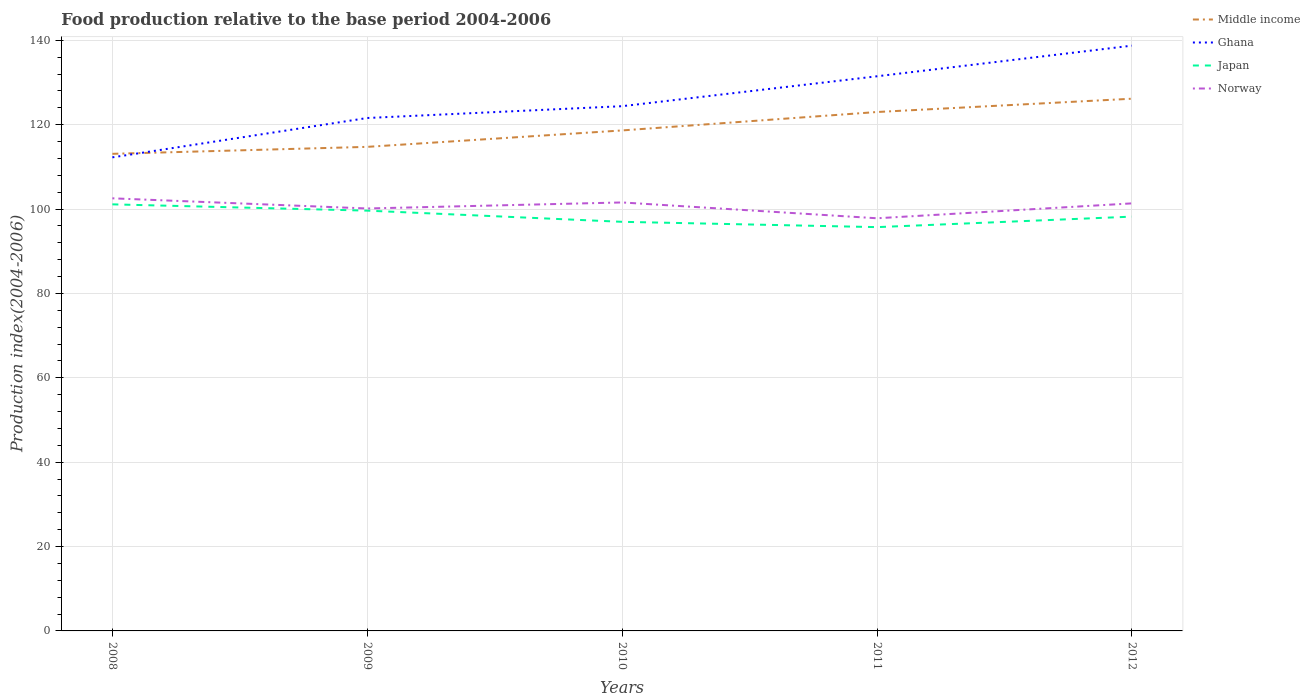How many different coloured lines are there?
Provide a short and direct response. 4. Is the number of lines equal to the number of legend labels?
Make the answer very short. Yes. Across all years, what is the maximum food production index in Japan?
Offer a terse response. 95.72. In which year was the food production index in Middle income maximum?
Ensure brevity in your answer.  2008. What is the total food production index in Middle income in the graph?
Offer a terse response. -3.9. What is the difference between the highest and the second highest food production index in Norway?
Ensure brevity in your answer.  4.73. What is the difference between the highest and the lowest food production index in Japan?
Give a very brief answer. 2. Is the food production index in Norway strictly greater than the food production index in Ghana over the years?
Ensure brevity in your answer.  Yes. How many lines are there?
Ensure brevity in your answer.  4. How many years are there in the graph?
Your response must be concise. 5. Are the values on the major ticks of Y-axis written in scientific E-notation?
Give a very brief answer. No. Does the graph contain any zero values?
Your answer should be compact. No. Does the graph contain grids?
Ensure brevity in your answer.  Yes. How are the legend labels stacked?
Offer a very short reply. Vertical. What is the title of the graph?
Ensure brevity in your answer.  Food production relative to the base period 2004-2006. Does "Kuwait" appear as one of the legend labels in the graph?
Your response must be concise. No. What is the label or title of the X-axis?
Offer a terse response. Years. What is the label or title of the Y-axis?
Make the answer very short. Production index(2004-2006). What is the Production index(2004-2006) of Middle income in 2008?
Your response must be concise. 113.1. What is the Production index(2004-2006) of Ghana in 2008?
Ensure brevity in your answer.  112.26. What is the Production index(2004-2006) of Japan in 2008?
Ensure brevity in your answer.  101.12. What is the Production index(2004-2006) in Norway in 2008?
Offer a very short reply. 102.55. What is the Production index(2004-2006) in Middle income in 2009?
Offer a very short reply. 114.75. What is the Production index(2004-2006) in Ghana in 2009?
Your answer should be compact. 121.59. What is the Production index(2004-2006) of Japan in 2009?
Ensure brevity in your answer.  99.63. What is the Production index(2004-2006) of Norway in 2009?
Your answer should be compact. 100.14. What is the Production index(2004-2006) in Middle income in 2010?
Provide a short and direct response. 118.64. What is the Production index(2004-2006) in Ghana in 2010?
Your answer should be very brief. 124.39. What is the Production index(2004-2006) in Japan in 2010?
Keep it short and to the point. 96.98. What is the Production index(2004-2006) in Norway in 2010?
Provide a short and direct response. 101.57. What is the Production index(2004-2006) of Middle income in 2011?
Your answer should be compact. 123.01. What is the Production index(2004-2006) of Ghana in 2011?
Your response must be concise. 131.48. What is the Production index(2004-2006) of Japan in 2011?
Provide a short and direct response. 95.72. What is the Production index(2004-2006) in Norway in 2011?
Ensure brevity in your answer.  97.82. What is the Production index(2004-2006) of Middle income in 2012?
Give a very brief answer. 126.16. What is the Production index(2004-2006) in Ghana in 2012?
Keep it short and to the point. 138.74. What is the Production index(2004-2006) in Japan in 2012?
Your answer should be compact. 98.21. What is the Production index(2004-2006) of Norway in 2012?
Ensure brevity in your answer.  101.35. Across all years, what is the maximum Production index(2004-2006) of Middle income?
Make the answer very short. 126.16. Across all years, what is the maximum Production index(2004-2006) of Ghana?
Provide a succinct answer. 138.74. Across all years, what is the maximum Production index(2004-2006) in Japan?
Your response must be concise. 101.12. Across all years, what is the maximum Production index(2004-2006) in Norway?
Keep it short and to the point. 102.55. Across all years, what is the minimum Production index(2004-2006) of Middle income?
Ensure brevity in your answer.  113.1. Across all years, what is the minimum Production index(2004-2006) of Ghana?
Your answer should be compact. 112.26. Across all years, what is the minimum Production index(2004-2006) in Japan?
Give a very brief answer. 95.72. Across all years, what is the minimum Production index(2004-2006) of Norway?
Provide a succinct answer. 97.82. What is the total Production index(2004-2006) of Middle income in the graph?
Offer a very short reply. 595.66. What is the total Production index(2004-2006) in Ghana in the graph?
Make the answer very short. 628.46. What is the total Production index(2004-2006) of Japan in the graph?
Give a very brief answer. 491.66. What is the total Production index(2004-2006) in Norway in the graph?
Offer a very short reply. 503.43. What is the difference between the Production index(2004-2006) in Middle income in 2008 and that in 2009?
Give a very brief answer. -1.65. What is the difference between the Production index(2004-2006) in Ghana in 2008 and that in 2009?
Offer a very short reply. -9.33. What is the difference between the Production index(2004-2006) of Japan in 2008 and that in 2009?
Give a very brief answer. 1.49. What is the difference between the Production index(2004-2006) in Norway in 2008 and that in 2009?
Provide a succinct answer. 2.41. What is the difference between the Production index(2004-2006) of Middle income in 2008 and that in 2010?
Your response must be concise. -5.55. What is the difference between the Production index(2004-2006) in Ghana in 2008 and that in 2010?
Make the answer very short. -12.13. What is the difference between the Production index(2004-2006) of Japan in 2008 and that in 2010?
Provide a short and direct response. 4.14. What is the difference between the Production index(2004-2006) of Norway in 2008 and that in 2010?
Provide a succinct answer. 0.98. What is the difference between the Production index(2004-2006) in Middle income in 2008 and that in 2011?
Offer a very short reply. -9.91. What is the difference between the Production index(2004-2006) in Ghana in 2008 and that in 2011?
Your answer should be compact. -19.22. What is the difference between the Production index(2004-2006) in Japan in 2008 and that in 2011?
Keep it short and to the point. 5.4. What is the difference between the Production index(2004-2006) in Norway in 2008 and that in 2011?
Provide a succinct answer. 4.73. What is the difference between the Production index(2004-2006) of Middle income in 2008 and that in 2012?
Ensure brevity in your answer.  -13.07. What is the difference between the Production index(2004-2006) of Ghana in 2008 and that in 2012?
Keep it short and to the point. -26.48. What is the difference between the Production index(2004-2006) of Japan in 2008 and that in 2012?
Your response must be concise. 2.91. What is the difference between the Production index(2004-2006) in Norway in 2008 and that in 2012?
Keep it short and to the point. 1.2. What is the difference between the Production index(2004-2006) of Middle income in 2009 and that in 2010?
Give a very brief answer. -3.9. What is the difference between the Production index(2004-2006) in Japan in 2009 and that in 2010?
Keep it short and to the point. 2.65. What is the difference between the Production index(2004-2006) in Norway in 2009 and that in 2010?
Offer a very short reply. -1.43. What is the difference between the Production index(2004-2006) in Middle income in 2009 and that in 2011?
Make the answer very short. -8.26. What is the difference between the Production index(2004-2006) of Ghana in 2009 and that in 2011?
Your response must be concise. -9.89. What is the difference between the Production index(2004-2006) of Japan in 2009 and that in 2011?
Ensure brevity in your answer.  3.91. What is the difference between the Production index(2004-2006) of Norway in 2009 and that in 2011?
Your answer should be compact. 2.32. What is the difference between the Production index(2004-2006) in Middle income in 2009 and that in 2012?
Provide a short and direct response. -11.41. What is the difference between the Production index(2004-2006) in Ghana in 2009 and that in 2012?
Keep it short and to the point. -17.15. What is the difference between the Production index(2004-2006) in Japan in 2009 and that in 2012?
Make the answer very short. 1.42. What is the difference between the Production index(2004-2006) in Norway in 2009 and that in 2012?
Ensure brevity in your answer.  -1.21. What is the difference between the Production index(2004-2006) in Middle income in 2010 and that in 2011?
Your response must be concise. -4.37. What is the difference between the Production index(2004-2006) in Ghana in 2010 and that in 2011?
Give a very brief answer. -7.09. What is the difference between the Production index(2004-2006) in Japan in 2010 and that in 2011?
Make the answer very short. 1.26. What is the difference between the Production index(2004-2006) of Norway in 2010 and that in 2011?
Your response must be concise. 3.75. What is the difference between the Production index(2004-2006) in Middle income in 2010 and that in 2012?
Offer a terse response. -7.52. What is the difference between the Production index(2004-2006) of Ghana in 2010 and that in 2012?
Keep it short and to the point. -14.35. What is the difference between the Production index(2004-2006) of Japan in 2010 and that in 2012?
Your answer should be compact. -1.23. What is the difference between the Production index(2004-2006) of Norway in 2010 and that in 2012?
Provide a short and direct response. 0.22. What is the difference between the Production index(2004-2006) in Middle income in 2011 and that in 2012?
Your answer should be compact. -3.15. What is the difference between the Production index(2004-2006) of Ghana in 2011 and that in 2012?
Make the answer very short. -7.26. What is the difference between the Production index(2004-2006) in Japan in 2011 and that in 2012?
Your answer should be compact. -2.49. What is the difference between the Production index(2004-2006) of Norway in 2011 and that in 2012?
Give a very brief answer. -3.53. What is the difference between the Production index(2004-2006) in Middle income in 2008 and the Production index(2004-2006) in Ghana in 2009?
Provide a succinct answer. -8.49. What is the difference between the Production index(2004-2006) in Middle income in 2008 and the Production index(2004-2006) in Japan in 2009?
Your answer should be very brief. 13.47. What is the difference between the Production index(2004-2006) of Middle income in 2008 and the Production index(2004-2006) of Norway in 2009?
Your answer should be very brief. 12.96. What is the difference between the Production index(2004-2006) of Ghana in 2008 and the Production index(2004-2006) of Japan in 2009?
Your answer should be compact. 12.63. What is the difference between the Production index(2004-2006) in Ghana in 2008 and the Production index(2004-2006) in Norway in 2009?
Offer a very short reply. 12.12. What is the difference between the Production index(2004-2006) of Japan in 2008 and the Production index(2004-2006) of Norway in 2009?
Give a very brief answer. 0.98. What is the difference between the Production index(2004-2006) in Middle income in 2008 and the Production index(2004-2006) in Ghana in 2010?
Keep it short and to the point. -11.29. What is the difference between the Production index(2004-2006) in Middle income in 2008 and the Production index(2004-2006) in Japan in 2010?
Offer a very short reply. 16.12. What is the difference between the Production index(2004-2006) of Middle income in 2008 and the Production index(2004-2006) of Norway in 2010?
Provide a succinct answer. 11.53. What is the difference between the Production index(2004-2006) of Ghana in 2008 and the Production index(2004-2006) of Japan in 2010?
Make the answer very short. 15.28. What is the difference between the Production index(2004-2006) in Ghana in 2008 and the Production index(2004-2006) in Norway in 2010?
Give a very brief answer. 10.69. What is the difference between the Production index(2004-2006) of Japan in 2008 and the Production index(2004-2006) of Norway in 2010?
Provide a short and direct response. -0.45. What is the difference between the Production index(2004-2006) in Middle income in 2008 and the Production index(2004-2006) in Ghana in 2011?
Offer a terse response. -18.38. What is the difference between the Production index(2004-2006) of Middle income in 2008 and the Production index(2004-2006) of Japan in 2011?
Ensure brevity in your answer.  17.38. What is the difference between the Production index(2004-2006) in Middle income in 2008 and the Production index(2004-2006) in Norway in 2011?
Your response must be concise. 15.28. What is the difference between the Production index(2004-2006) of Ghana in 2008 and the Production index(2004-2006) of Japan in 2011?
Offer a very short reply. 16.54. What is the difference between the Production index(2004-2006) in Ghana in 2008 and the Production index(2004-2006) in Norway in 2011?
Make the answer very short. 14.44. What is the difference between the Production index(2004-2006) in Middle income in 2008 and the Production index(2004-2006) in Ghana in 2012?
Offer a terse response. -25.64. What is the difference between the Production index(2004-2006) in Middle income in 2008 and the Production index(2004-2006) in Japan in 2012?
Your answer should be compact. 14.89. What is the difference between the Production index(2004-2006) in Middle income in 2008 and the Production index(2004-2006) in Norway in 2012?
Provide a short and direct response. 11.75. What is the difference between the Production index(2004-2006) of Ghana in 2008 and the Production index(2004-2006) of Japan in 2012?
Provide a succinct answer. 14.05. What is the difference between the Production index(2004-2006) in Ghana in 2008 and the Production index(2004-2006) in Norway in 2012?
Make the answer very short. 10.91. What is the difference between the Production index(2004-2006) of Japan in 2008 and the Production index(2004-2006) of Norway in 2012?
Offer a terse response. -0.23. What is the difference between the Production index(2004-2006) of Middle income in 2009 and the Production index(2004-2006) of Ghana in 2010?
Your response must be concise. -9.64. What is the difference between the Production index(2004-2006) in Middle income in 2009 and the Production index(2004-2006) in Japan in 2010?
Keep it short and to the point. 17.77. What is the difference between the Production index(2004-2006) in Middle income in 2009 and the Production index(2004-2006) in Norway in 2010?
Your answer should be very brief. 13.18. What is the difference between the Production index(2004-2006) of Ghana in 2009 and the Production index(2004-2006) of Japan in 2010?
Give a very brief answer. 24.61. What is the difference between the Production index(2004-2006) of Ghana in 2009 and the Production index(2004-2006) of Norway in 2010?
Your answer should be compact. 20.02. What is the difference between the Production index(2004-2006) in Japan in 2009 and the Production index(2004-2006) in Norway in 2010?
Provide a short and direct response. -1.94. What is the difference between the Production index(2004-2006) of Middle income in 2009 and the Production index(2004-2006) of Ghana in 2011?
Ensure brevity in your answer.  -16.73. What is the difference between the Production index(2004-2006) of Middle income in 2009 and the Production index(2004-2006) of Japan in 2011?
Your response must be concise. 19.03. What is the difference between the Production index(2004-2006) of Middle income in 2009 and the Production index(2004-2006) of Norway in 2011?
Offer a very short reply. 16.93. What is the difference between the Production index(2004-2006) of Ghana in 2009 and the Production index(2004-2006) of Japan in 2011?
Offer a terse response. 25.87. What is the difference between the Production index(2004-2006) of Ghana in 2009 and the Production index(2004-2006) of Norway in 2011?
Offer a very short reply. 23.77. What is the difference between the Production index(2004-2006) of Japan in 2009 and the Production index(2004-2006) of Norway in 2011?
Your response must be concise. 1.81. What is the difference between the Production index(2004-2006) in Middle income in 2009 and the Production index(2004-2006) in Ghana in 2012?
Your answer should be compact. -23.99. What is the difference between the Production index(2004-2006) of Middle income in 2009 and the Production index(2004-2006) of Japan in 2012?
Give a very brief answer. 16.54. What is the difference between the Production index(2004-2006) of Middle income in 2009 and the Production index(2004-2006) of Norway in 2012?
Ensure brevity in your answer.  13.4. What is the difference between the Production index(2004-2006) in Ghana in 2009 and the Production index(2004-2006) in Japan in 2012?
Give a very brief answer. 23.38. What is the difference between the Production index(2004-2006) of Ghana in 2009 and the Production index(2004-2006) of Norway in 2012?
Your answer should be very brief. 20.24. What is the difference between the Production index(2004-2006) of Japan in 2009 and the Production index(2004-2006) of Norway in 2012?
Offer a very short reply. -1.72. What is the difference between the Production index(2004-2006) in Middle income in 2010 and the Production index(2004-2006) in Ghana in 2011?
Make the answer very short. -12.84. What is the difference between the Production index(2004-2006) in Middle income in 2010 and the Production index(2004-2006) in Japan in 2011?
Ensure brevity in your answer.  22.92. What is the difference between the Production index(2004-2006) in Middle income in 2010 and the Production index(2004-2006) in Norway in 2011?
Give a very brief answer. 20.82. What is the difference between the Production index(2004-2006) of Ghana in 2010 and the Production index(2004-2006) of Japan in 2011?
Make the answer very short. 28.67. What is the difference between the Production index(2004-2006) of Ghana in 2010 and the Production index(2004-2006) of Norway in 2011?
Offer a terse response. 26.57. What is the difference between the Production index(2004-2006) of Japan in 2010 and the Production index(2004-2006) of Norway in 2011?
Provide a short and direct response. -0.84. What is the difference between the Production index(2004-2006) of Middle income in 2010 and the Production index(2004-2006) of Ghana in 2012?
Your answer should be very brief. -20.1. What is the difference between the Production index(2004-2006) in Middle income in 2010 and the Production index(2004-2006) in Japan in 2012?
Offer a very short reply. 20.43. What is the difference between the Production index(2004-2006) of Middle income in 2010 and the Production index(2004-2006) of Norway in 2012?
Give a very brief answer. 17.29. What is the difference between the Production index(2004-2006) of Ghana in 2010 and the Production index(2004-2006) of Japan in 2012?
Keep it short and to the point. 26.18. What is the difference between the Production index(2004-2006) in Ghana in 2010 and the Production index(2004-2006) in Norway in 2012?
Provide a succinct answer. 23.04. What is the difference between the Production index(2004-2006) of Japan in 2010 and the Production index(2004-2006) of Norway in 2012?
Give a very brief answer. -4.37. What is the difference between the Production index(2004-2006) in Middle income in 2011 and the Production index(2004-2006) in Ghana in 2012?
Your response must be concise. -15.73. What is the difference between the Production index(2004-2006) in Middle income in 2011 and the Production index(2004-2006) in Japan in 2012?
Provide a succinct answer. 24.8. What is the difference between the Production index(2004-2006) in Middle income in 2011 and the Production index(2004-2006) in Norway in 2012?
Your response must be concise. 21.66. What is the difference between the Production index(2004-2006) of Ghana in 2011 and the Production index(2004-2006) of Japan in 2012?
Your answer should be very brief. 33.27. What is the difference between the Production index(2004-2006) in Ghana in 2011 and the Production index(2004-2006) in Norway in 2012?
Provide a succinct answer. 30.13. What is the difference between the Production index(2004-2006) of Japan in 2011 and the Production index(2004-2006) of Norway in 2012?
Make the answer very short. -5.63. What is the average Production index(2004-2006) in Middle income per year?
Offer a very short reply. 119.13. What is the average Production index(2004-2006) in Ghana per year?
Offer a very short reply. 125.69. What is the average Production index(2004-2006) of Japan per year?
Keep it short and to the point. 98.33. What is the average Production index(2004-2006) of Norway per year?
Make the answer very short. 100.69. In the year 2008, what is the difference between the Production index(2004-2006) in Middle income and Production index(2004-2006) in Ghana?
Offer a terse response. 0.84. In the year 2008, what is the difference between the Production index(2004-2006) of Middle income and Production index(2004-2006) of Japan?
Your answer should be compact. 11.98. In the year 2008, what is the difference between the Production index(2004-2006) in Middle income and Production index(2004-2006) in Norway?
Make the answer very short. 10.55. In the year 2008, what is the difference between the Production index(2004-2006) of Ghana and Production index(2004-2006) of Japan?
Provide a short and direct response. 11.14. In the year 2008, what is the difference between the Production index(2004-2006) in Ghana and Production index(2004-2006) in Norway?
Your response must be concise. 9.71. In the year 2008, what is the difference between the Production index(2004-2006) in Japan and Production index(2004-2006) in Norway?
Ensure brevity in your answer.  -1.43. In the year 2009, what is the difference between the Production index(2004-2006) in Middle income and Production index(2004-2006) in Ghana?
Your answer should be very brief. -6.84. In the year 2009, what is the difference between the Production index(2004-2006) of Middle income and Production index(2004-2006) of Japan?
Give a very brief answer. 15.12. In the year 2009, what is the difference between the Production index(2004-2006) in Middle income and Production index(2004-2006) in Norway?
Provide a succinct answer. 14.61. In the year 2009, what is the difference between the Production index(2004-2006) in Ghana and Production index(2004-2006) in Japan?
Your answer should be compact. 21.96. In the year 2009, what is the difference between the Production index(2004-2006) in Ghana and Production index(2004-2006) in Norway?
Provide a succinct answer. 21.45. In the year 2009, what is the difference between the Production index(2004-2006) in Japan and Production index(2004-2006) in Norway?
Keep it short and to the point. -0.51. In the year 2010, what is the difference between the Production index(2004-2006) in Middle income and Production index(2004-2006) in Ghana?
Ensure brevity in your answer.  -5.75. In the year 2010, what is the difference between the Production index(2004-2006) in Middle income and Production index(2004-2006) in Japan?
Give a very brief answer. 21.66. In the year 2010, what is the difference between the Production index(2004-2006) in Middle income and Production index(2004-2006) in Norway?
Your response must be concise. 17.07. In the year 2010, what is the difference between the Production index(2004-2006) of Ghana and Production index(2004-2006) of Japan?
Keep it short and to the point. 27.41. In the year 2010, what is the difference between the Production index(2004-2006) of Ghana and Production index(2004-2006) of Norway?
Your answer should be compact. 22.82. In the year 2010, what is the difference between the Production index(2004-2006) of Japan and Production index(2004-2006) of Norway?
Your answer should be compact. -4.59. In the year 2011, what is the difference between the Production index(2004-2006) of Middle income and Production index(2004-2006) of Ghana?
Make the answer very short. -8.47. In the year 2011, what is the difference between the Production index(2004-2006) of Middle income and Production index(2004-2006) of Japan?
Your answer should be compact. 27.29. In the year 2011, what is the difference between the Production index(2004-2006) of Middle income and Production index(2004-2006) of Norway?
Provide a short and direct response. 25.19. In the year 2011, what is the difference between the Production index(2004-2006) in Ghana and Production index(2004-2006) in Japan?
Ensure brevity in your answer.  35.76. In the year 2011, what is the difference between the Production index(2004-2006) of Ghana and Production index(2004-2006) of Norway?
Provide a short and direct response. 33.66. In the year 2012, what is the difference between the Production index(2004-2006) of Middle income and Production index(2004-2006) of Ghana?
Offer a very short reply. -12.58. In the year 2012, what is the difference between the Production index(2004-2006) of Middle income and Production index(2004-2006) of Japan?
Give a very brief answer. 27.95. In the year 2012, what is the difference between the Production index(2004-2006) in Middle income and Production index(2004-2006) in Norway?
Ensure brevity in your answer.  24.81. In the year 2012, what is the difference between the Production index(2004-2006) in Ghana and Production index(2004-2006) in Japan?
Provide a short and direct response. 40.53. In the year 2012, what is the difference between the Production index(2004-2006) in Ghana and Production index(2004-2006) in Norway?
Your response must be concise. 37.39. In the year 2012, what is the difference between the Production index(2004-2006) of Japan and Production index(2004-2006) of Norway?
Give a very brief answer. -3.14. What is the ratio of the Production index(2004-2006) of Middle income in 2008 to that in 2009?
Give a very brief answer. 0.99. What is the ratio of the Production index(2004-2006) of Ghana in 2008 to that in 2009?
Provide a succinct answer. 0.92. What is the ratio of the Production index(2004-2006) in Norway in 2008 to that in 2009?
Provide a short and direct response. 1.02. What is the ratio of the Production index(2004-2006) of Middle income in 2008 to that in 2010?
Provide a succinct answer. 0.95. What is the ratio of the Production index(2004-2006) of Ghana in 2008 to that in 2010?
Provide a short and direct response. 0.9. What is the ratio of the Production index(2004-2006) in Japan in 2008 to that in 2010?
Ensure brevity in your answer.  1.04. What is the ratio of the Production index(2004-2006) of Norway in 2008 to that in 2010?
Your answer should be very brief. 1.01. What is the ratio of the Production index(2004-2006) in Middle income in 2008 to that in 2011?
Your answer should be very brief. 0.92. What is the ratio of the Production index(2004-2006) of Ghana in 2008 to that in 2011?
Offer a terse response. 0.85. What is the ratio of the Production index(2004-2006) of Japan in 2008 to that in 2011?
Your response must be concise. 1.06. What is the ratio of the Production index(2004-2006) of Norway in 2008 to that in 2011?
Give a very brief answer. 1.05. What is the ratio of the Production index(2004-2006) in Middle income in 2008 to that in 2012?
Provide a succinct answer. 0.9. What is the ratio of the Production index(2004-2006) in Ghana in 2008 to that in 2012?
Give a very brief answer. 0.81. What is the ratio of the Production index(2004-2006) in Japan in 2008 to that in 2012?
Provide a short and direct response. 1.03. What is the ratio of the Production index(2004-2006) of Norway in 2008 to that in 2012?
Make the answer very short. 1.01. What is the ratio of the Production index(2004-2006) in Middle income in 2009 to that in 2010?
Provide a short and direct response. 0.97. What is the ratio of the Production index(2004-2006) of Ghana in 2009 to that in 2010?
Your answer should be compact. 0.98. What is the ratio of the Production index(2004-2006) in Japan in 2009 to that in 2010?
Offer a very short reply. 1.03. What is the ratio of the Production index(2004-2006) in Norway in 2009 to that in 2010?
Your response must be concise. 0.99. What is the ratio of the Production index(2004-2006) of Middle income in 2009 to that in 2011?
Make the answer very short. 0.93. What is the ratio of the Production index(2004-2006) of Ghana in 2009 to that in 2011?
Your answer should be compact. 0.92. What is the ratio of the Production index(2004-2006) in Japan in 2009 to that in 2011?
Provide a short and direct response. 1.04. What is the ratio of the Production index(2004-2006) of Norway in 2009 to that in 2011?
Offer a terse response. 1.02. What is the ratio of the Production index(2004-2006) in Middle income in 2009 to that in 2012?
Provide a succinct answer. 0.91. What is the ratio of the Production index(2004-2006) in Ghana in 2009 to that in 2012?
Provide a short and direct response. 0.88. What is the ratio of the Production index(2004-2006) in Japan in 2009 to that in 2012?
Ensure brevity in your answer.  1.01. What is the ratio of the Production index(2004-2006) of Middle income in 2010 to that in 2011?
Keep it short and to the point. 0.96. What is the ratio of the Production index(2004-2006) of Ghana in 2010 to that in 2011?
Provide a succinct answer. 0.95. What is the ratio of the Production index(2004-2006) of Japan in 2010 to that in 2011?
Keep it short and to the point. 1.01. What is the ratio of the Production index(2004-2006) in Norway in 2010 to that in 2011?
Your response must be concise. 1.04. What is the ratio of the Production index(2004-2006) of Middle income in 2010 to that in 2012?
Ensure brevity in your answer.  0.94. What is the ratio of the Production index(2004-2006) in Ghana in 2010 to that in 2012?
Your response must be concise. 0.9. What is the ratio of the Production index(2004-2006) in Japan in 2010 to that in 2012?
Offer a terse response. 0.99. What is the ratio of the Production index(2004-2006) of Norway in 2010 to that in 2012?
Give a very brief answer. 1. What is the ratio of the Production index(2004-2006) of Ghana in 2011 to that in 2012?
Your response must be concise. 0.95. What is the ratio of the Production index(2004-2006) in Japan in 2011 to that in 2012?
Give a very brief answer. 0.97. What is the ratio of the Production index(2004-2006) of Norway in 2011 to that in 2012?
Your answer should be compact. 0.97. What is the difference between the highest and the second highest Production index(2004-2006) of Middle income?
Offer a terse response. 3.15. What is the difference between the highest and the second highest Production index(2004-2006) of Ghana?
Offer a terse response. 7.26. What is the difference between the highest and the second highest Production index(2004-2006) of Japan?
Provide a short and direct response. 1.49. What is the difference between the highest and the second highest Production index(2004-2006) of Norway?
Make the answer very short. 0.98. What is the difference between the highest and the lowest Production index(2004-2006) of Middle income?
Offer a very short reply. 13.07. What is the difference between the highest and the lowest Production index(2004-2006) of Ghana?
Your response must be concise. 26.48. What is the difference between the highest and the lowest Production index(2004-2006) of Japan?
Your answer should be compact. 5.4. What is the difference between the highest and the lowest Production index(2004-2006) of Norway?
Your answer should be very brief. 4.73. 